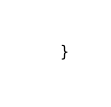Convert code to text. <code><loc_0><loc_0><loc_500><loc_500><_C++_>    }
</code> 